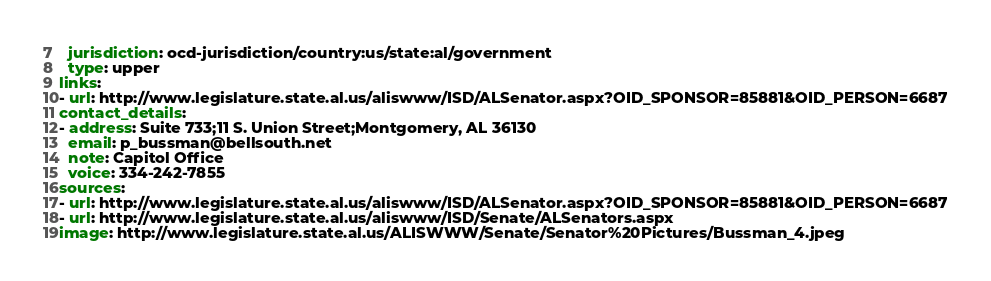Convert code to text. <code><loc_0><loc_0><loc_500><loc_500><_YAML_>  jurisdiction: ocd-jurisdiction/country:us/state:al/government
  type: upper
links:
- url: http://www.legislature.state.al.us/aliswww/ISD/ALSenator.aspx?OID_SPONSOR=85881&OID_PERSON=6687
contact_details:
- address: Suite 733;11 S. Union Street;Montgomery, AL 36130
  email: p_bussman@bellsouth.net
  note: Capitol Office
  voice: 334-242-7855
sources:
- url: http://www.legislature.state.al.us/aliswww/ISD/ALSenator.aspx?OID_SPONSOR=85881&OID_PERSON=6687
- url: http://www.legislature.state.al.us/aliswww/ISD/Senate/ALSenators.aspx
image: http://www.legislature.state.al.us/ALISWWW/Senate/Senator%20Pictures/Bussman_4.jpeg
</code> 